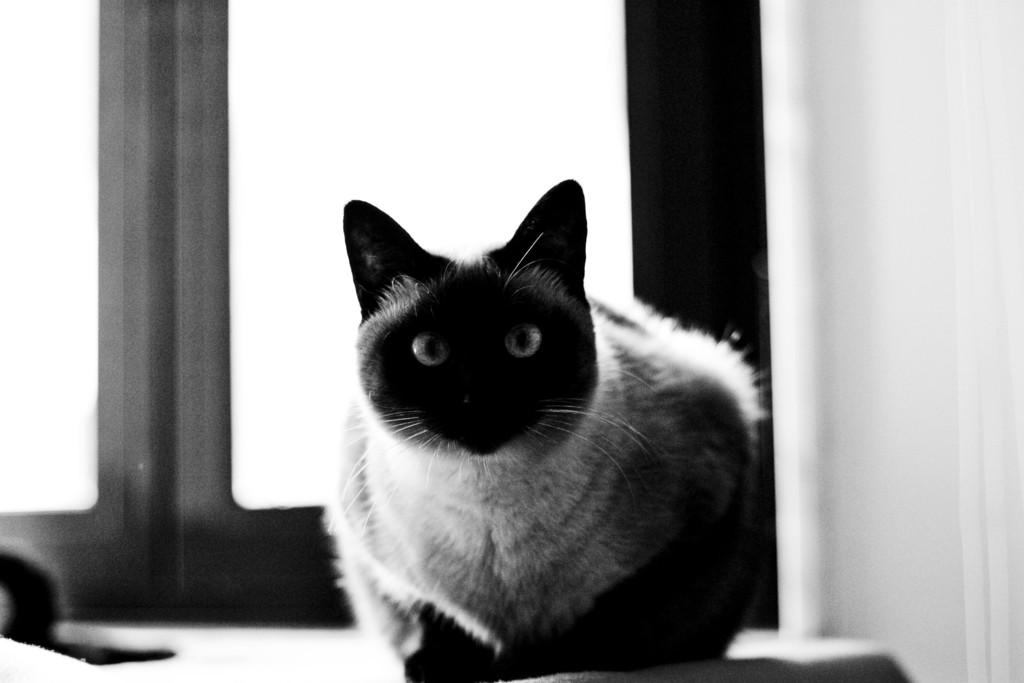What is the color scheme of the image? The image is black and white. What animal can be seen in the image? There is a cat in the image. What is the cat doing in the image? The cat is sitting on a surface. What can be seen in the background of the image? There is a window in the background of the image. What type of toothpaste is the cat using in the image? There is no toothpaste present in the image, and the cat is not using any toothpaste. 